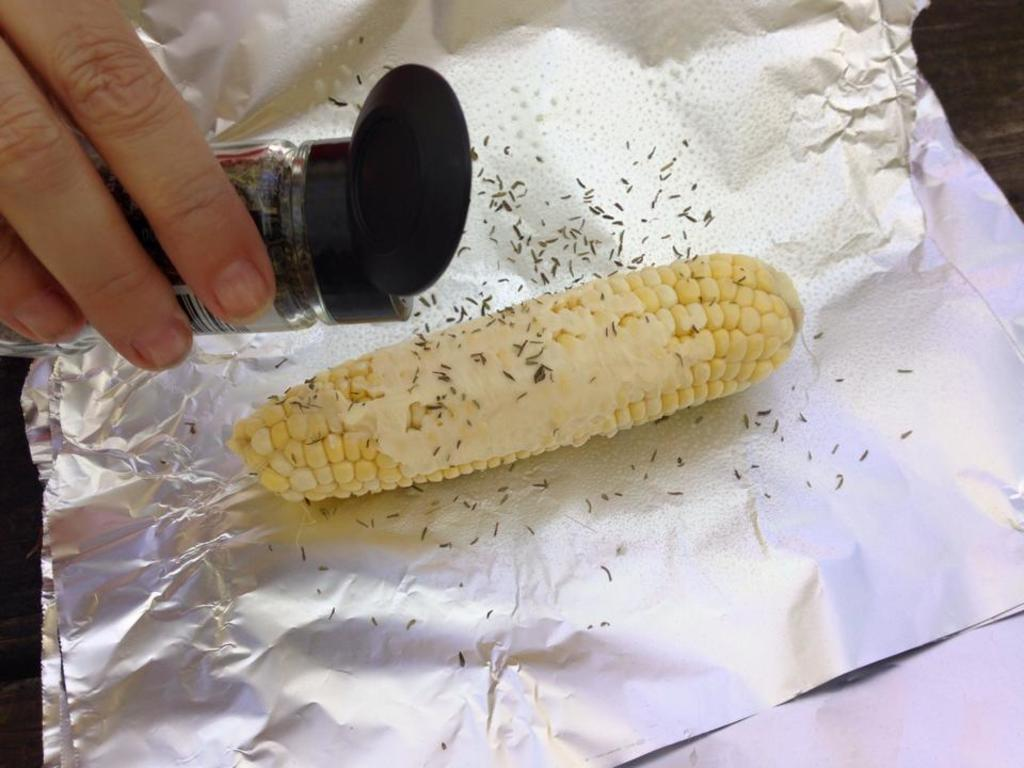What is the person in the image doing? The person in the image is holding a bottle in their hand. What else can be seen in the image besides the person? There is a corn vegetable on a foil and cumin seeds present in the image. What might the person be using the bottle for? It is unclear from the image what the person is using the bottle for, but it could be related to the corn vegetable or cumin seeds. Can you describe the setting of the image? The image is likely taken in a room, as there are no outdoor elements visible. What type of polish is being applied to the corn vegetable in the image? There is no polish present in the image, and the corn vegetable does not appear to be receiving any treatment. 